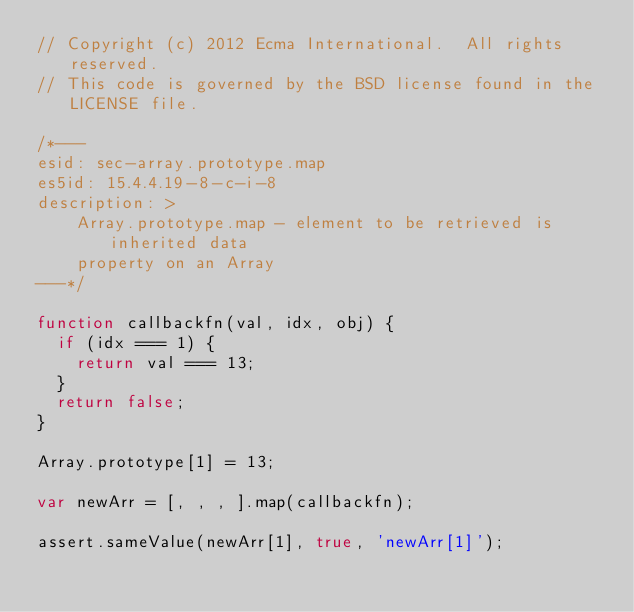Convert code to text. <code><loc_0><loc_0><loc_500><loc_500><_JavaScript_>// Copyright (c) 2012 Ecma International.  All rights reserved.
// This code is governed by the BSD license found in the LICENSE file.

/*---
esid: sec-array.prototype.map
es5id: 15.4.4.19-8-c-i-8
description: >
    Array.prototype.map - element to be retrieved is inherited data
    property on an Array
---*/

function callbackfn(val, idx, obj) {
  if (idx === 1) {
    return val === 13;
  }
  return false;
}

Array.prototype[1] = 13;

var newArr = [, , , ].map(callbackfn);

assert.sameValue(newArr[1], true, 'newArr[1]');
</code> 